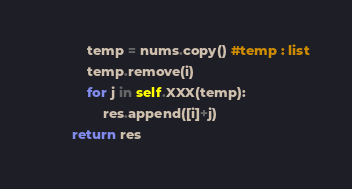Convert code to text. <code><loc_0><loc_0><loc_500><loc_500><_Python_>            temp = nums.copy() #temp : list
            temp.remove(i)
            for j in self.XXX(temp):
                res.append([i]+j)
        return res

</code> 